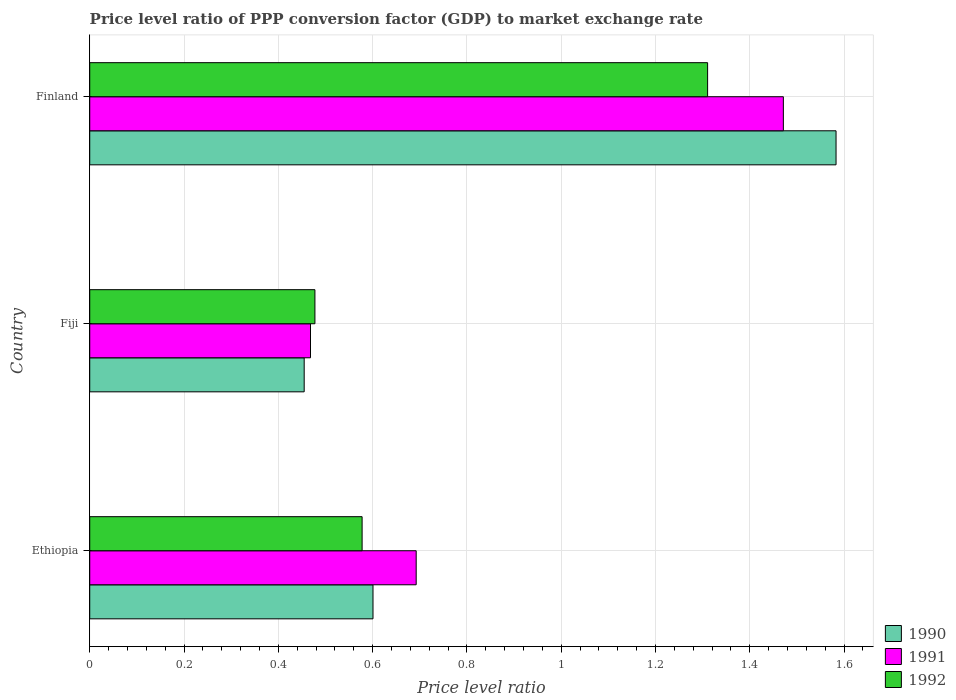How many different coloured bars are there?
Provide a short and direct response. 3. How many groups of bars are there?
Keep it short and to the point. 3. How many bars are there on the 3rd tick from the top?
Your answer should be very brief. 3. What is the label of the 3rd group of bars from the top?
Your response must be concise. Ethiopia. In how many cases, is the number of bars for a given country not equal to the number of legend labels?
Ensure brevity in your answer.  0. What is the price level ratio in 1992 in Ethiopia?
Your answer should be very brief. 0.58. Across all countries, what is the maximum price level ratio in 1991?
Your answer should be very brief. 1.47. Across all countries, what is the minimum price level ratio in 1990?
Offer a terse response. 0.45. In which country was the price level ratio in 1992 maximum?
Give a very brief answer. Finland. In which country was the price level ratio in 1991 minimum?
Your response must be concise. Fiji. What is the total price level ratio in 1991 in the graph?
Your answer should be compact. 2.63. What is the difference between the price level ratio in 1992 in Ethiopia and that in Fiji?
Your answer should be very brief. 0.1. What is the difference between the price level ratio in 1990 in Fiji and the price level ratio in 1991 in Ethiopia?
Ensure brevity in your answer.  -0.24. What is the average price level ratio in 1990 per country?
Your response must be concise. 0.88. What is the difference between the price level ratio in 1990 and price level ratio in 1991 in Fiji?
Your answer should be very brief. -0.01. What is the ratio of the price level ratio in 1992 in Ethiopia to that in Fiji?
Make the answer very short. 1.21. Is the price level ratio in 1991 in Ethiopia less than that in Finland?
Your response must be concise. Yes. Is the difference between the price level ratio in 1990 in Ethiopia and Fiji greater than the difference between the price level ratio in 1991 in Ethiopia and Fiji?
Ensure brevity in your answer.  No. What is the difference between the highest and the second highest price level ratio in 1991?
Your answer should be very brief. 0.78. What is the difference between the highest and the lowest price level ratio in 1992?
Provide a succinct answer. 0.83. In how many countries, is the price level ratio in 1990 greater than the average price level ratio in 1990 taken over all countries?
Your answer should be compact. 1. Is the sum of the price level ratio in 1991 in Ethiopia and Fiji greater than the maximum price level ratio in 1992 across all countries?
Your answer should be compact. No. What does the 2nd bar from the bottom in Fiji represents?
Offer a very short reply. 1991. How many bars are there?
Provide a short and direct response. 9. Are all the bars in the graph horizontal?
Your answer should be compact. Yes. What is the difference between two consecutive major ticks on the X-axis?
Provide a short and direct response. 0.2. Does the graph contain grids?
Your answer should be compact. Yes. How are the legend labels stacked?
Provide a succinct answer. Vertical. What is the title of the graph?
Offer a very short reply. Price level ratio of PPP conversion factor (GDP) to market exchange rate. What is the label or title of the X-axis?
Offer a very short reply. Price level ratio. What is the Price level ratio in 1990 in Ethiopia?
Give a very brief answer. 0.6. What is the Price level ratio in 1991 in Ethiopia?
Make the answer very short. 0.69. What is the Price level ratio of 1992 in Ethiopia?
Your answer should be compact. 0.58. What is the Price level ratio in 1990 in Fiji?
Your answer should be very brief. 0.45. What is the Price level ratio in 1991 in Fiji?
Give a very brief answer. 0.47. What is the Price level ratio of 1992 in Fiji?
Give a very brief answer. 0.48. What is the Price level ratio in 1990 in Finland?
Ensure brevity in your answer.  1.58. What is the Price level ratio of 1991 in Finland?
Offer a terse response. 1.47. What is the Price level ratio in 1992 in Finland?
Give a very brief answer. 1.31. Across all countries, what is the maximum Price level ratio of 1990?
Ensure brevity in your answer.  1.58. Across all countries, what is the maximum Price level ratio of 1991?
Give a very brief answer. 1.47. Across all countries, what is the maximum Price level ratio of 1992?
Keep it short and to the point. 1.31. Across all countries, what is the minimum Price level ratio in 1990?
Your answer should be compact. 0.45. Across all countries, what is the minimum Price level ratio in 1991?
Provide a short and direct response. 0.47. Across all countries, what is the minimum Price level ratio in 1992?
Offer a very short reply. 0.48. What is the total Price level ratio in 1990 in the graph?
Give a very brief answer. 2.64. What is the total Price level ratio of 1991 in the graph?
Make the answer very short. 2.63. What is the total Price level ratio of 1992 in the graph?
Make the answer very short. 2.37. What is the difference between the Price level ratio in 1990 in Ethiopia and that in Fiji?
Your answer should be compact. 0.15. What is the difference between the Price level ratio in 1991 in Ethiopia and that in Fiji?
Keep it short and to the point. 0.22. What is the difference between the Price level ratio of 1992 in Ethiopia and that in Fiji?
Your answer should be compact. 0.1. What is the difference between the Price level ratio in 1990 in Ethiopia and that in Finland?
Your answer should be very brief. -0.98. What is the difference between the Price level ratio in 1991 in Ethiopia and that in Finland?
Provide a succinct answer. -0.78. What is the difference between the Price level ratio in 1992 in Ethiopia and that in Finland?
Provide a short and direct response. -0.73. What is the difference between the Price level ratio of 1990 in Fiji and that in Finland?
Make the answer very short. -1.13. What is the difference between the Price level ratio in 1991 in Fiji and that in Finland?
Your answer should be compact. -1. What is the difference between the Price level ratio in 1992 in Fiji and that in Finland?
Provide a succinct answer. -0.83. What is the difference between the Price level ratio of 1990 in Ethiopia and the Price level ratio of 1991 in Fiji?
Your answer should be very brief. 0.13. What is the difference between the Price level ratio in 1990 in Ethiopia and the Price level ratio in 1992 in Fiji?
Your response must be concise. 0.12. What is the difference between the Price level ratio in 1991 in Ethiopia and the Price level ratio in 1992 in Fiji?
Offer a very short reply. 0.21. What is the difference between the Price level ratio of 1990 in Ethiopia and the Price level ratio of 1991 in Finland?
Your answer should be compact. -0.87. What is the difference between the Price level ratio of 1990 in Ethiopia and the Price level ratio of 1992 in Finland?
Give a very brief answer. -0.71. What is the difference between the Price level ratio in 1991 in Ethiopia and the Price level ratio in 1992 in Finland?
Offer a terse response. -0.62. What is the difference between the Price level ratio in 1990 in Fiji and the Price level ratio in 1991 in Finland?
Offer a very short reply. -1.02. What is the difference between the Price level ratio in 1990 in Fiji and the Price level ratio in 1992 in Finland?
Provide a short and direct response. -0.86. What is the difference between the Price level ratio in 1991 in Fiji and the Price level ratio in 1992 in Finland?
Make the answer very short. -0.84. What is the average Price level ratio of 1990 per country?
Ensure brevity in your answer.  0.88. What is the average Price level ratio of 1991 per country?
Ensure brevity in your answer.  0.88. What is the average Price level ratio of 1992 per country?
Keep it short and to the point. 0.79. What is the difference between the Price level ratio of 1990 and Price level ratio of 1991 in Ethiopia?
Offer a very short reply. -0.09. What is the difference between the Price level ratio of 1990 and Price level ratio of 1992 in Ethiopia?
Provide a short and direct response. 0.02. What is the difference between the Price level ratio of 1991 and Price level ratio of 1992 in Ethiopia?
Offer a very short reply. 0.11. What is the difference between the Price level ratio of 1990 and Price level ratio of 1991 in Fiji?
Your response must be concise. -0.01. What is the difference between the Price level ratio of 1990 and Price level ratio of 1992 in Fiji?
Your response must be concise. -0.02. What is the difference between the Price level ratio of 1991 and Price level ratio of 1992 in Fiji?
Offer a terse response. -0.01. What is the difference between the Price level ratio of 1990 and Price level ratio of 1991 in Finland?
Ensure brevity in your answer.  0.11. What is the difference between the Price level ratio of 1990 and Price level ratio of 1992 in Finland?
Keep it short and to the point. 0.27. What is the difference between the Price level ratio of 1991 and Price level ratio of 1992 in Finland?
Keep it short and to the point. 0.16. What is the ratio of the Price level ratio in 1990 in Ethiopia to that in Fiji?
Provide a succinct answer. 1.32. What is the ratio of the Price level ratio of 1991 in Ethiopia to that in Fiji?
Your answer should be compact. 1.48. What is the ratio of the Price level ratio of 1992 in Ethiopia to that in Fiji?
Offer a terse response. 1.21. What is the ratio of the Price level ratio of 1990 in Ethiopia to that in Finland?
Your answer should be compact. 0.38. What is the ratio of the Price level ratio of 1991 in Ethiopia to that in Finland?
Provide a short and direct response. 0.47. What is the ratio of the Price level ratio of 1992 in Ethiopia to that in Finland?
Provide a succinct answer. 0.44. What is the ratio of the Price level ratio in 1990 in Fiji to that in Finland?
Give a very brief answer. 0.29. What is the ratio of the Price level ratio of 1991 in Fiji to that in Finland?
Offer a very short reply. 0.32. What is the ratio of the Price level ratio of 1992 in Fiji to that in Finland?
Make the answer very short. 0.36. What is the difference between the highest and the second highest Price level ratio in 1990?
Provide a succinct answer. 0.98. What is the difference between the highest and the second highest Price level ratio of 1991?
Give a very brief answer. 0.78. What is the difference between the highest and the second highest Price level ratio in 1992?
Ensure brevity in your answer.  0.73. What is the difference between the highest and the lowest Price level ratio of 1990?
Ensure brevity in your answer.  1.13. What is the difference between the highest and the lowest Price level ratio in 1991?
Your response must be concise. 1. What is the difference between the highest and the lowest Price level ratio of 1992?
Offer a very short reply. 0.83. 